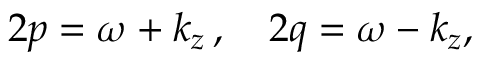<formula> <loc_0><loc_0><loc_500><loc_500>2 p = \omega + k _ { z } \, , \quad 2 q = \omega - k _ { z } ,</formula> 